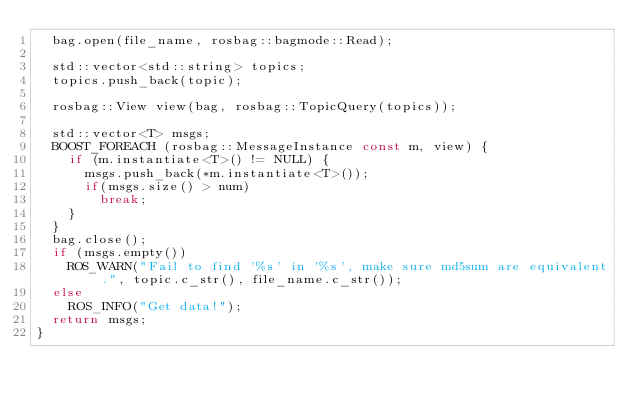<code> <loc_0><loc_0><loc_500><loc_500><_C++_>  bag.open(file_name, rosbag::bagmode::Read);

  std::vector<std::string> topics;
  topics.push_back(topic);

  rosbag::View view(bag, rosbag::TopicQuery(topics));

  std::vector<T> msgs;
  BOOST_FOREACH (rosbag::MessageInstance const m, view) {
    if (m.instantiate<T>() != NULL) {
      msgs.push_back(*m.instantiate<T>());
      if(msgs.size() > num)
        break;
    }
  }
  bag.close();
  if (msgs.empty())
    ROS_WARN("Fail to find '%s' in '%s', make sure md5sum are equivalent.", topic.c_str(), file_name.c_str());
  else
    ROS_INFO("Get data!");
  return msgs;
}
</code> 